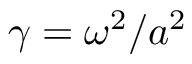<formula> <loc_0><loc_0><loc_500><loc_500>\gamma = \omega ^ { 2 } / a ^ { 2 }</formula> 